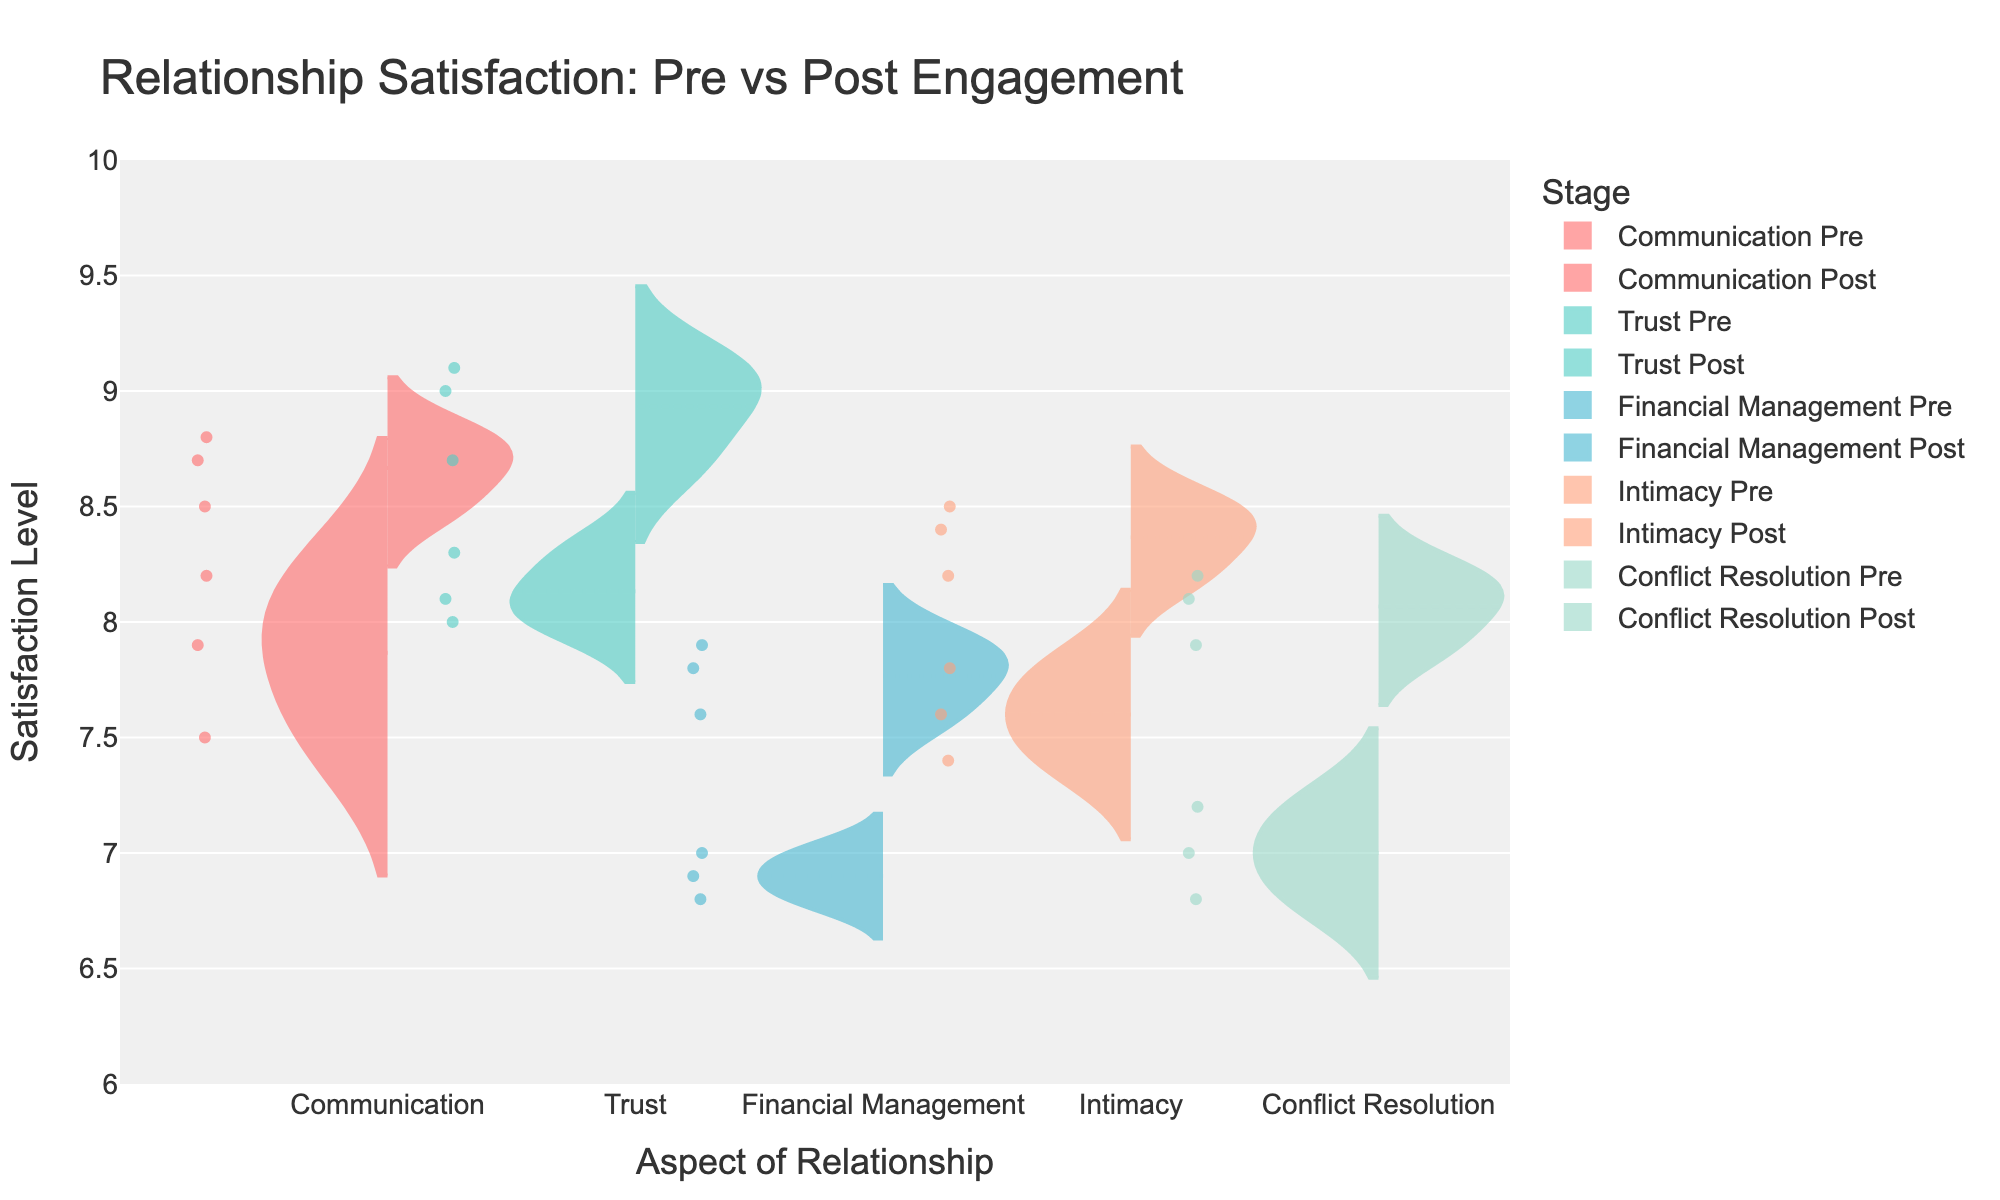what is the title of the plot? The title is usually located at the top center or top left of the plot. Here it reads "Relationship Satisfaction: Pre vs Post Engagement".
Answer: Relationship Satisfaction: Pre vs Post Engagement how many aspects of relationships are depicted in the plot? The x-axis shows the different aspects of relationships. Here there are five distinct aspects: "Communication", "Trust", "Financial Management", "Intimacy", and "Conflict Resolution".
Answer: 5 which aspect shows the highest satisfaction level post-engagement? We need to look at the post-engagement satisfaction levels across all aspects. The highest post-engagement mean satisfaction level appears in the "Trust" aspect, with values reaching up to 9.1.
Answer: Trust is the mean satisfaction level higher pre- or post-engagement for the "Financial Management" aspect? Observing both pre- and post-engagement distributions for "Financial Management", post-engagement levels are generally higher, with mean values slightly above 7.5 compared to pre-engagement values that hover around 6.9.
Answer: Post-engagement how does the satisfaction level in "Communication" change from pre-engagement to post-engagement? Comparing the pre-engagement to post-engagement satisfaction levels for "Communication", there is an overall increase from values around 7.5 to 8.8.
Answer: Increases what is the median satisfaction level for "Intimacy" pre-engagement? The median value splits the data in half. For "Intimacy" pre-engagement, the middle value among 7.6, 7.4, and 7.8 is 7.6.
Answer: 7.6 which aspect shows the smallest improvement in satisfaction level from pre-engagement to post-engagement? Comparing the difference between pre- and post-engagement satisfaction levels across all aspects, "Intimacy" shows the smallest improvement, changing only around 0.6 from ~7.6 to ~8.2.
Answer: Intimacy how does the distribution of "Conflict Resolution" satisfaction levels differ pre- and post-engagement? The plot shows that the satisfaction levels for "Conflict Resolution" increase from around 7.0 (pre-engagement) to about 8.1 (post-engagement), suggesting increased satisfaction after engagement.
Answer: Increase how many data points are there for "Trust" post-engagement? Counting the individual points for "Trust" post-engagement on the violin plot, we see there are three data points.
Answer: 3 is there any aspect where satisfaction levels remain relatively stable pre- and post-engagement? Observing each aspect's distributions, no aspect remains stable. Other aspects show noticeable increases post-engagement.
Answer: No 